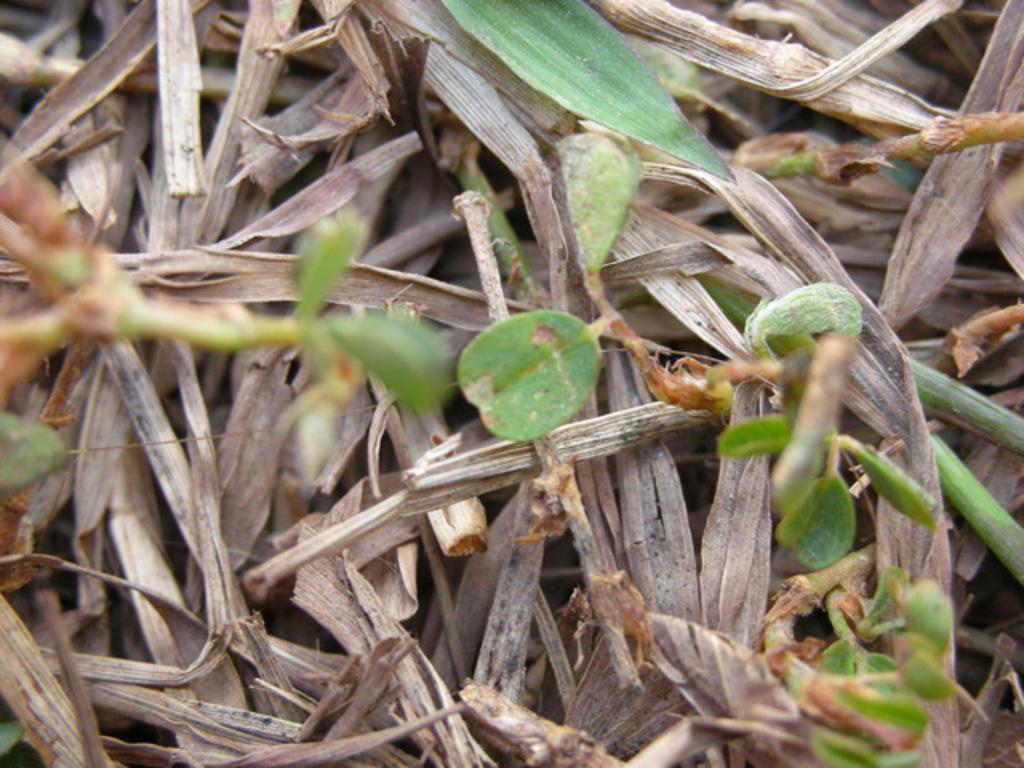Describe this image in one or two sentences. In this image there are leaves and dry grass. 